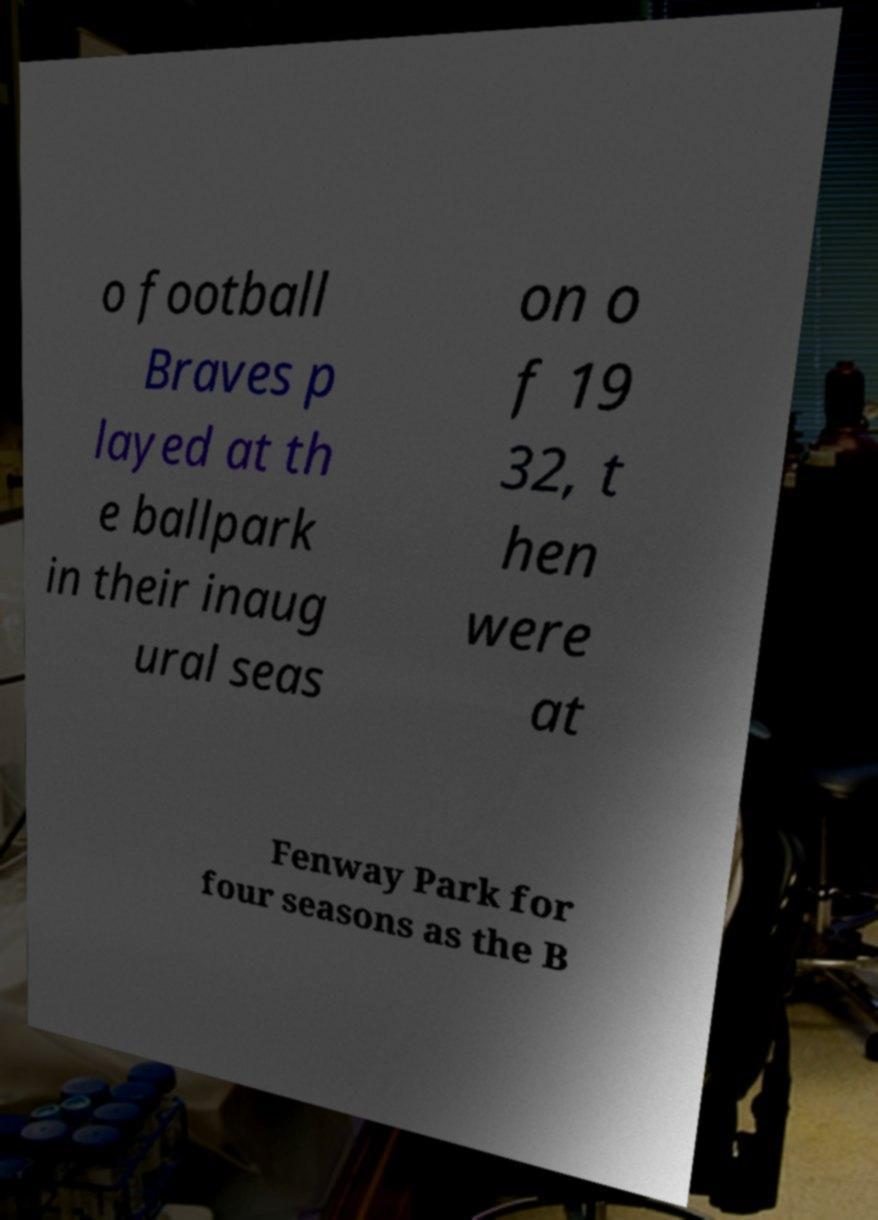What messages or text are displayed in this image? I need them in a readable, typed format. o football Braves p layed at th e ballpark in their inaug ural seas on o f 19 32, t hen were at Fenway Park for four seasons as the B 